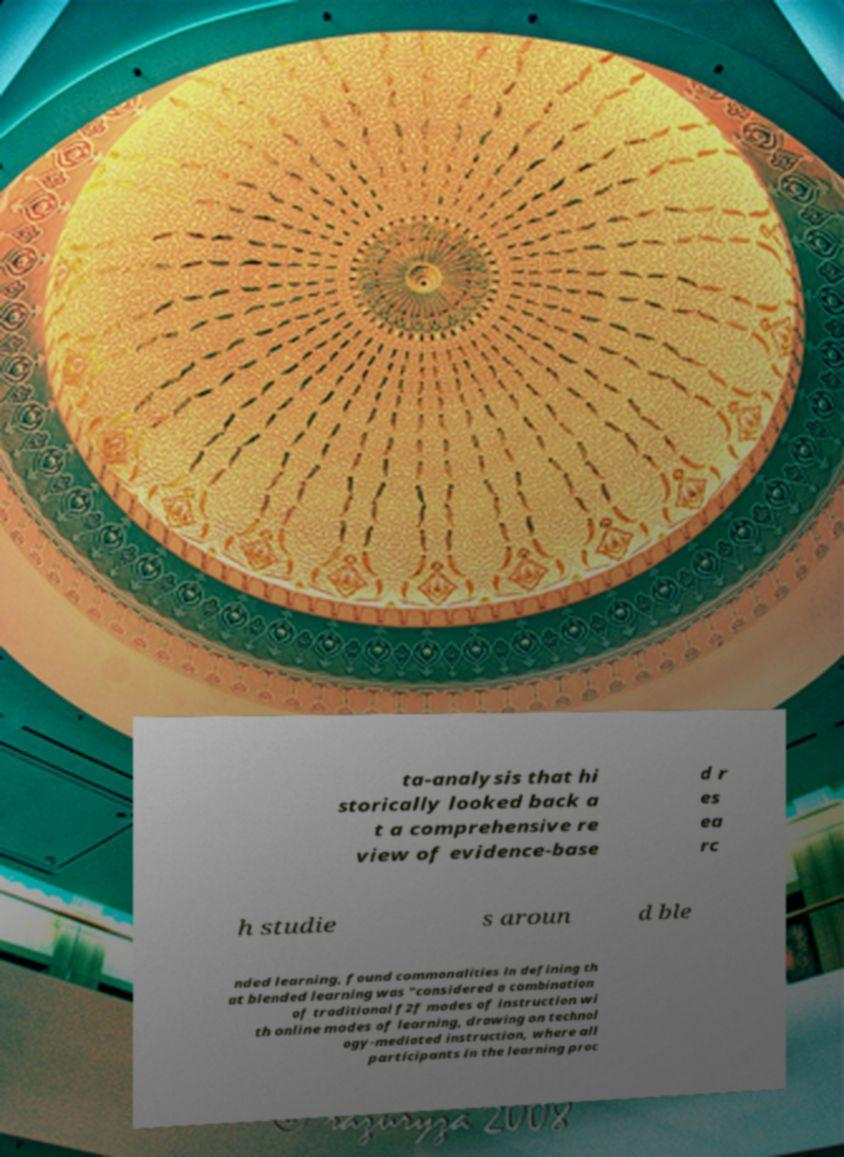Can you accurately transcribe the text from the provided image for me? ta-analysis that hi storically looked back a t a comprehensive re view of evidence-base d r es ea rc h studie s aroun d ble nded learning, found commonalities in defining th at blended learning was "considered a combination of traditional f2f modes of instruction wi th online modes of learning, drawing on technol ogy-mediated instruction, where all participants in the learning proc 